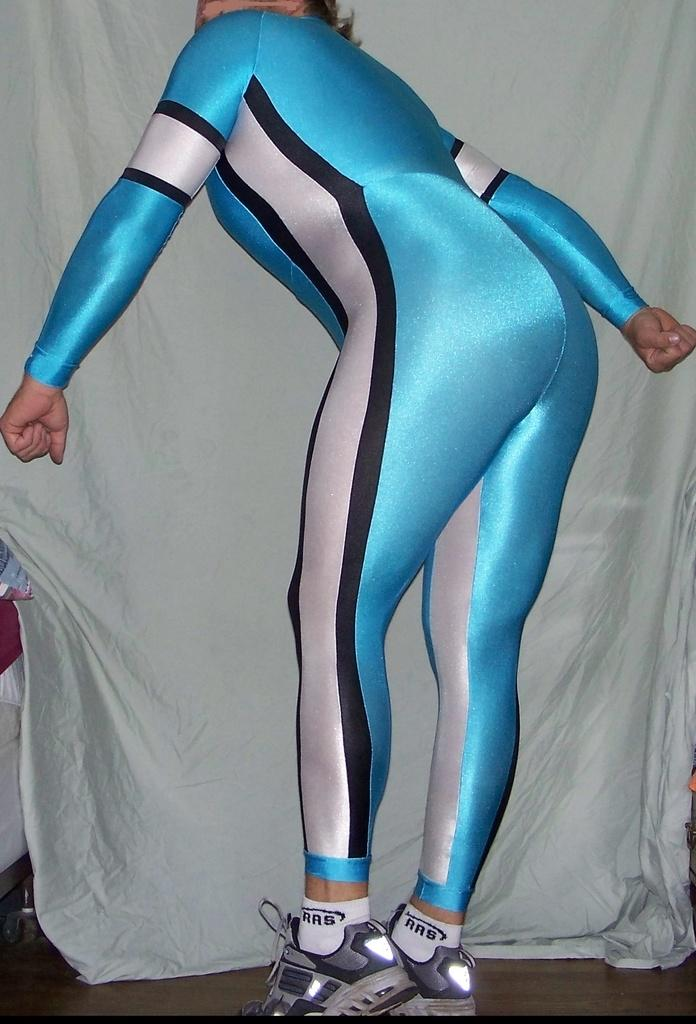<image>
Render a clear and concise summary of the photo. The skater has white socks on from the company RRB 